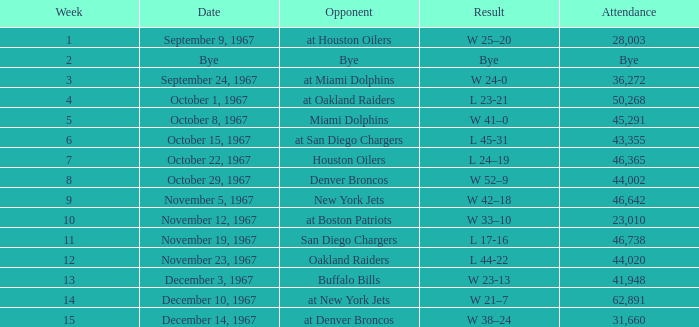What week did the September 9, 1967 game occur on? 1.0. 